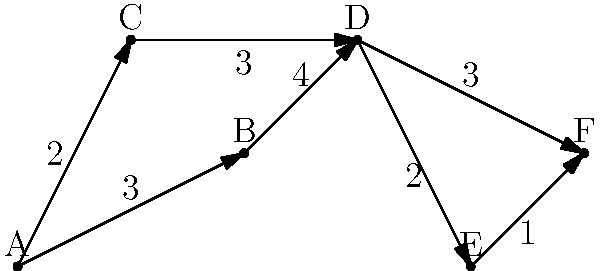As a film distributor, you need to efficiently distribute a new blockbuster movie from your main distribution center (city A) to a major theater chain's headquarters (city F). The graph represents the transportation network between cities, with the numbers on the edges indicating the time (in hours) required to transport the film between connected cities. What is the shortest time (in hours) required to transport the film from city A to city F? To solve this problem, we'll use Dijkstra's algorithm to find the shortest path from city A to city F. Here's the step-by-step process:

1. Initialize:
   - Set distance to A as 0, and all other cities as infinity.
   - Set all cities as unvisited.

2. Start from city A:
   - Update distances to neighboring cities:
     B: 3 hours
     C: 2 hours

3. Select the unvisited city with the smallest distance (C, 2 hours):
   - Update distance to D: 2 + 3 = 5 hours

4. Select the next unvisited city with the smallest distance (B, 3 hours):
   - Update distance to D: min(5, 3 + 4) = 5 hours (no change)

5. Select the next unvisited city (D, 5 hours):
   - Update distances:
     E: 5 + 2 = 7 hours
     F: 5 + 3 = 8 hours

6. Select the next unvisited city (E, 7 hours):
   - Update distance to F: min(8, 7 + 1) = 7 + 1 = 8 hours (no change)

7. The algorithm terminates as we've reached city F.

The shortest path is A → C → D → F, with a total time of 8 hours.
Answer: 8 hours 